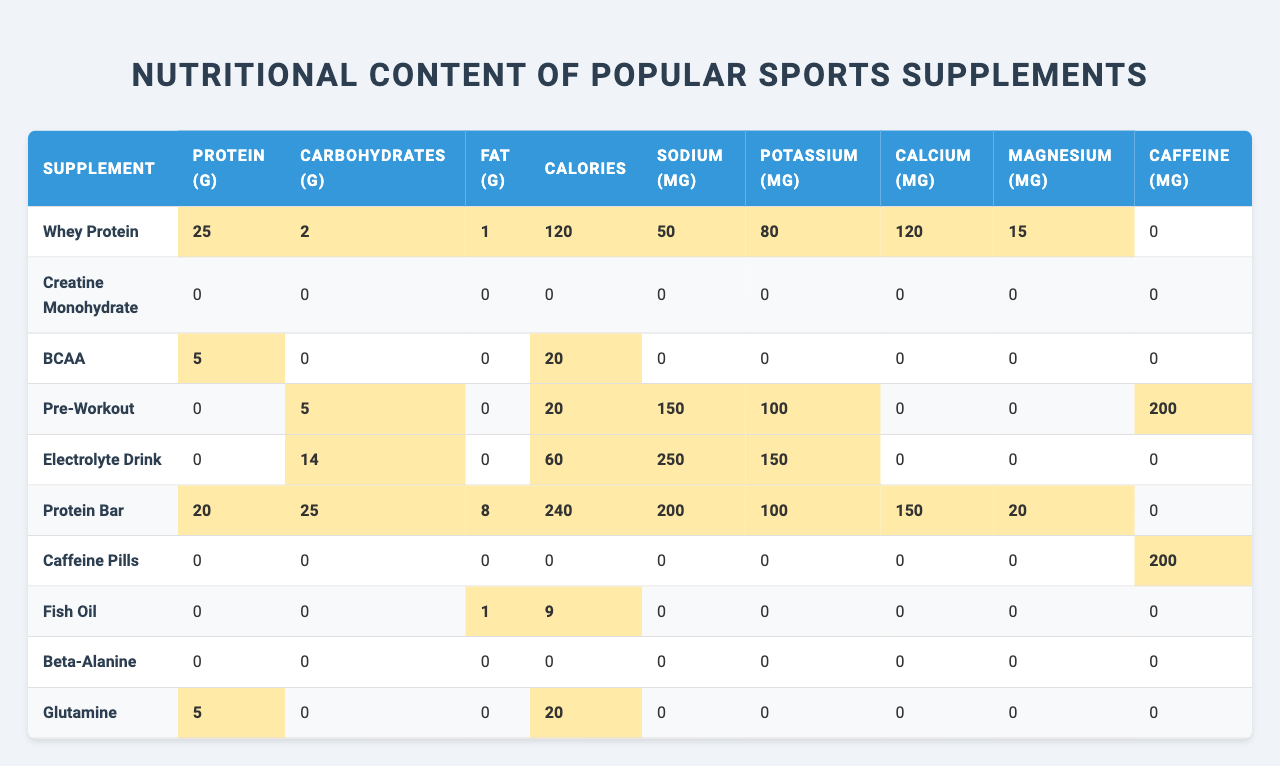What is the protein content in Whey Protein? The table shows that Whey Protein has a protein content of 25 grams.
Answer: 25 g Which supplement has the highest calorie count? By examining the table, the Protein Bar has the highest calorie count at 240 calories.
Answer: 240 calories Does Creatine Monohydrate contain any protein? The table indicates that Creatine Monohydrate has 0 grams of protein, which means it contains none.
Answer: No What is the total amount of carbohydrates in Protein Bar? The table shows Protein Bar has 25 grams of carbohydrates, which is a specific value provided.
Answer: 25 g Which supplement has the most sodium? Looking at the sodium content, Electrolyte Drink has 250 mg, which is the highest among all listed supplements.
Answer: 250 mg Calculate the average potassium content of all supplements. The potassium values from the table are 80, 0, 0, 100, 150, 0, 0, 0, 0, 0. The sum is 330 mg, divided by 10 supplements gives an average of 33 mg.
Answer: 33 mg Which supplement contains caffeine and how much? Caffeine Pills have 200 mg of caffeine, and Pre-Workout also contains 200 mg. Checking the table confirms this information.
Answer: Caffeine Pills – 200 mg, Pre-Workout – 200 mg Is there any supplement that has no fat content? By analyzing the table, we see that both Creatine Monohydrate and BCAA have 0 grams of fat, confirming they contain no fat.
Answer: Yes Which supplement has the highest protein to calorie ratio? To find the highest ratio, we look at the protein and calorie values: Whey Protein (25g protein / 120 calories) = 0.208, Protein Bar (20g protein / 240 calories) = 0.0833. Whey Protein has the highest ratio.
Answer: Whey Protein How much more calories does a Protein Bar have compared to Whey Protein? The Protein Bar has 240 calories, while Whey Protein has 120 calories. The difference is 240 - 120 = 120 calories.
Answer: 120 calories Which supplement contains the least amount of sodium? From the table, it shows that both BCAA and Fish Oil have 0 mg of sodium, making them the supplements with the least sodium.
Answer: 0 mg 